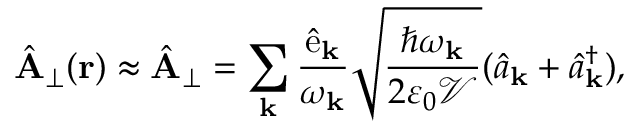Convert formula to latex. <formula><loc_0><loc_0><loc_500><loc_500>\hat { A } _ { \perp } ( { r } ) \approx \hat { A } _ { \perp } = \sum _ { k } \frac { \hat { { \mathcal { e } } } _ { k } } { \omega _ { k } } \sqrt { \frac { \hbar { \omega } _ { k } } { 2 \varepsilon _ { 0 } \mathcal { V } } } ( \hat { a } _ { k } + \hat { a } _ { k } ^ { \dagger } ) ,</formula> 